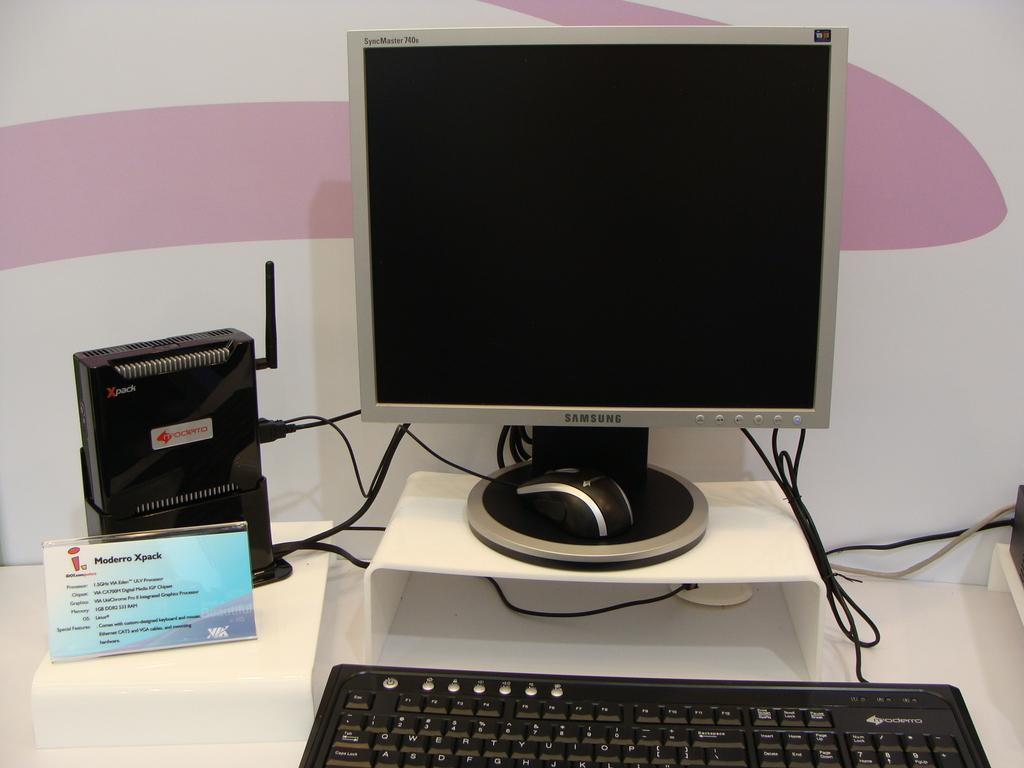Provide a one-sentence caption for the provided image. A Computer is on display with a Samsung monitor. 